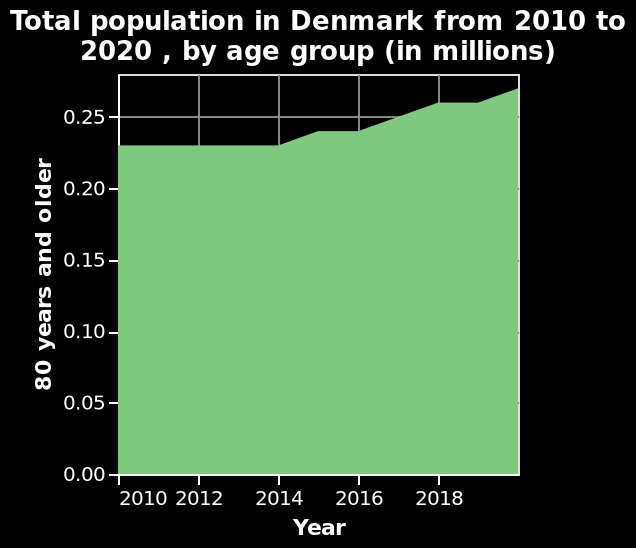<image>
please summary the statistics and relations of the chart from years 2010 to 2014 the population of 80+ remained the sameThe population of 80+ year old's then began to increase from 2014 to 2018. When did the increase in the population of 80+ year olds begin?  The increase in the population of 80+ year olds began in 2014. What happened to the population of 80+ year olds from 2010 to 2014?  The population of 80+ year olds remained the same from 2010 to 2014. 